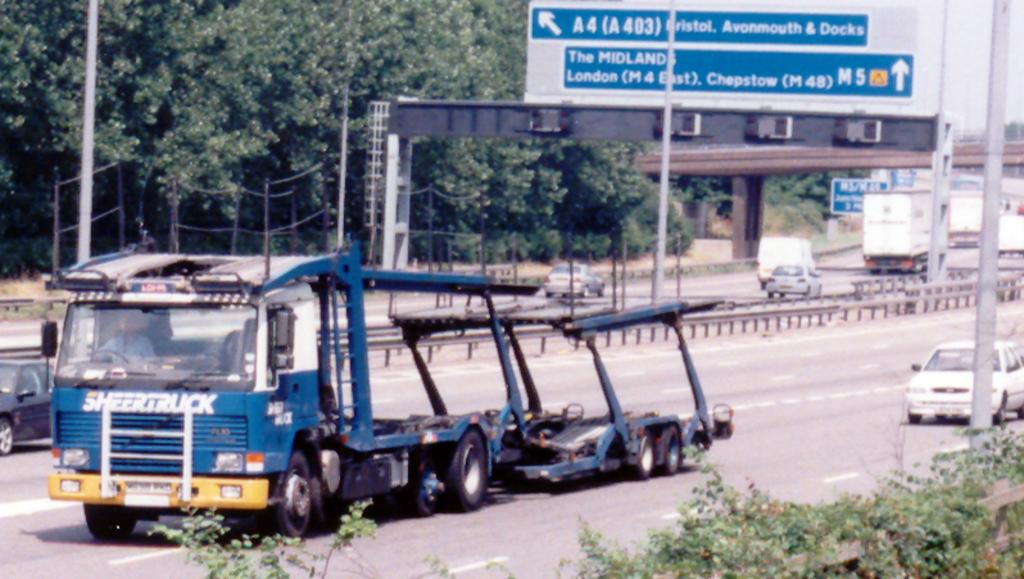What type of infrastructure is visible in the image? There are roads in the image. What is happening on the roads? There are many vehicles on the roads. What else can be seen along the roads? There are poles, sign boards, and trees on the sides of the roads. How many pets are sitting on the sign boards in the image? There are no pets present on the sign boards in the image. What type of ring can be seen on the poles in the image? There are no rings visible on the poles in the image. 